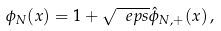Convert formula to latex. <formula><loc_0><loc_0><loc_500><loc_500>\phi _ { N } ( x ) = 1 + \sqrt { \ e p s } \hat { \phi } _ { N , + } ( x ) \, ,</formula> 